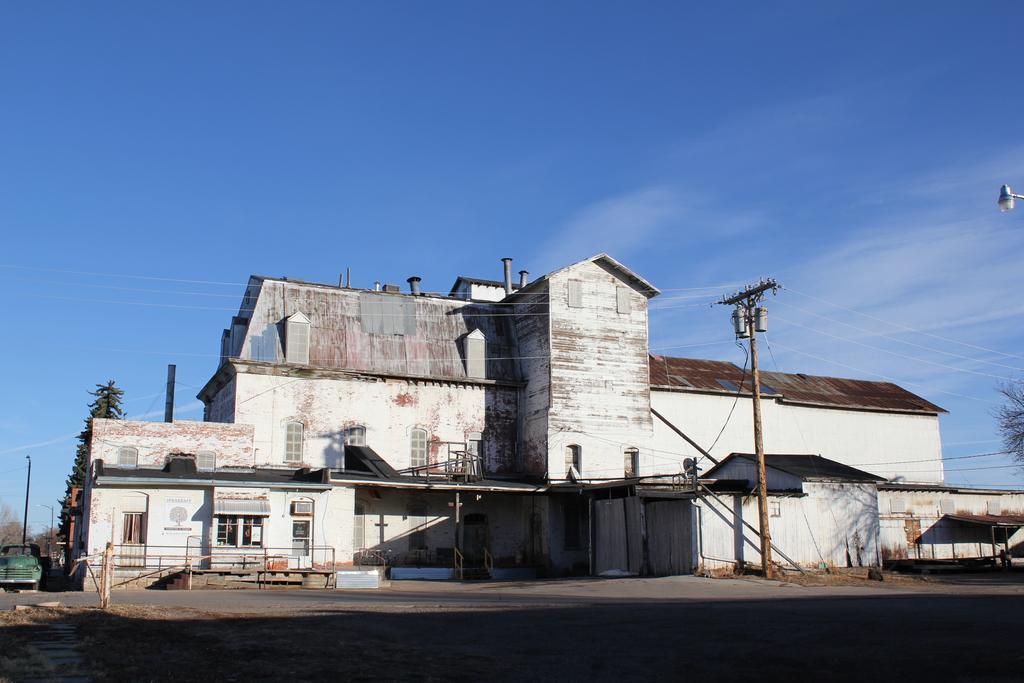Can you describe this image briefly? In this image there is a building, a vehicle, poles, electric poles and cables, a fence, a street light and some clouds in the sky. 